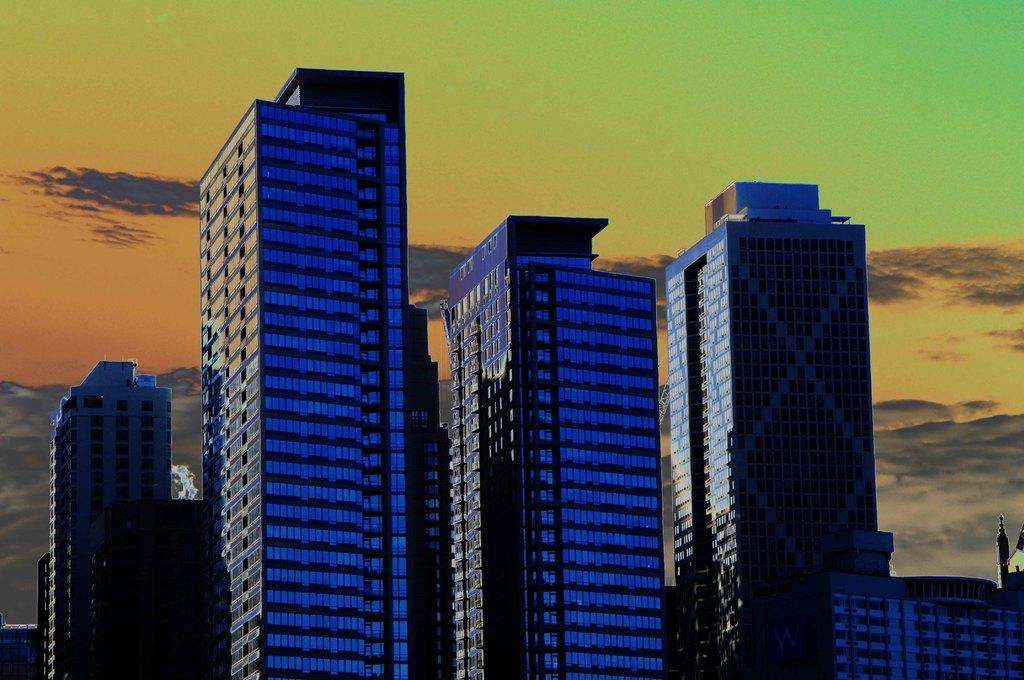What type of buildings can be seen in the image? There are skyscrapers in the image. What is visible in the background of the image? The sky is visible in the image. What can be observed in the sky? Clouds are present in the sky. What type of toothpaste is being used to clean the table in the image? There is no toothpaste or table present in the image. 